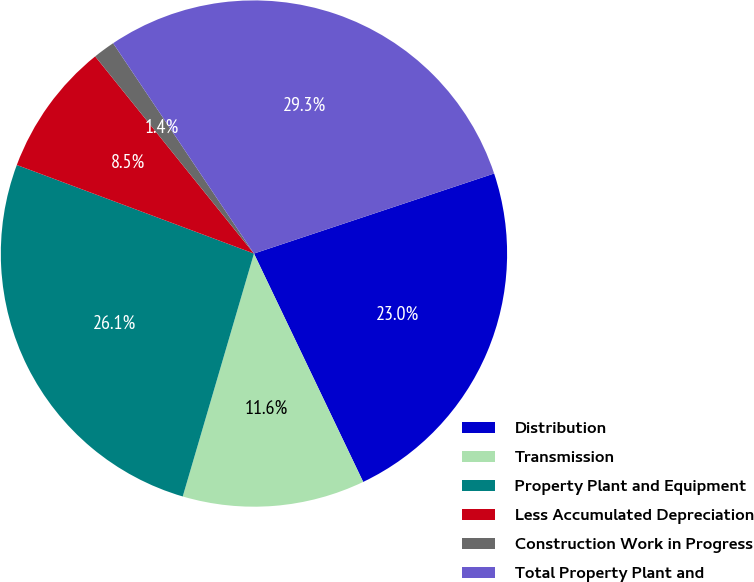<chart> <loc_0><loc_0><loc_500><loc_500><pie_chart><fcel>Distribution<fcel>Transmission<fcel>Property Plant and Equipment<fcel>Less Accumulated Depreciation<fcel>Construction Work in Progress<fcel>Total Property Plant and<nl><fcel>23.02%<fcel>11.64%<fcel>26.15%<fcel>8.52%<fcel>1.4%<fcel>29.27%<nl></chart> 